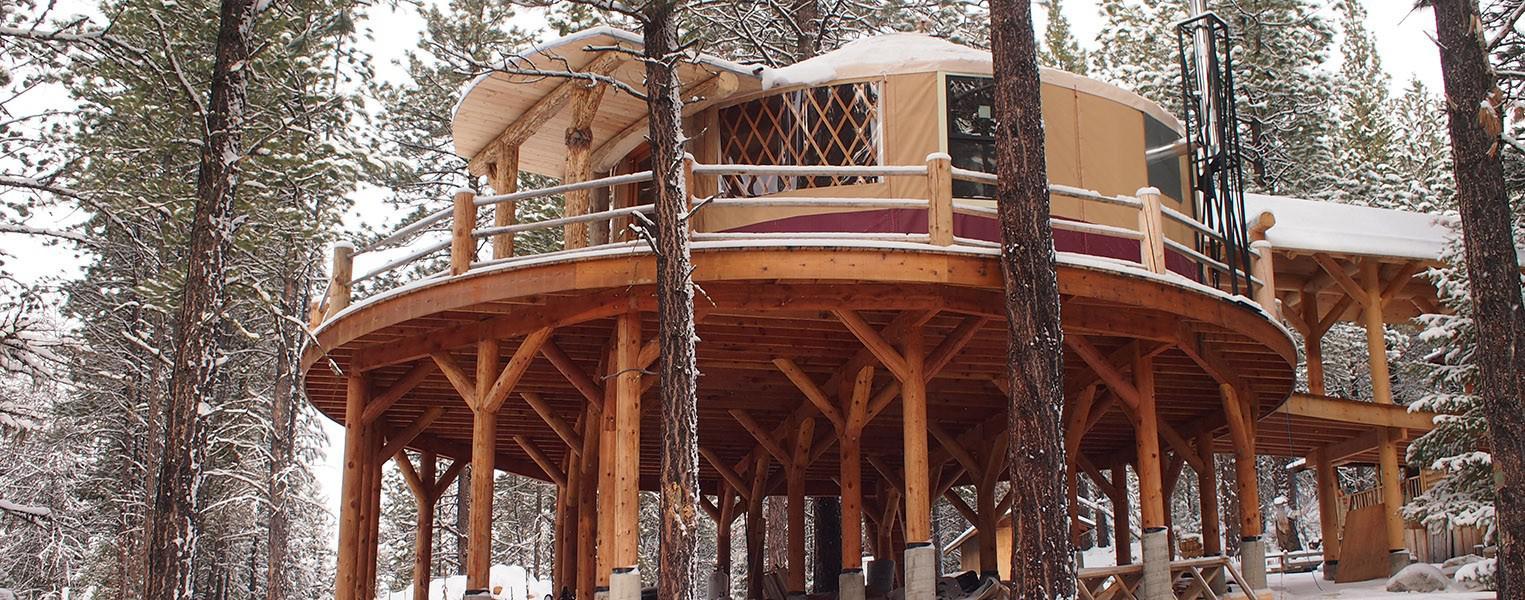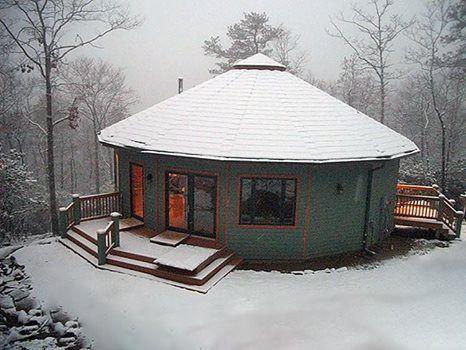The first image is the image on the left, the second image is the image on the right. Evaluate the accuracy of this statement regarding the images: "An image shows a round structure surrounded by a round railed deck, and the structure has lattice-work showing in the windows.". Is it true? Answer yes or no. Yes. The first image is the image on the left, the second image is the image on the right. Analyze the images presented: Is the assertion "Each image shows the snowy winter exterior of a yurt, with decking of wooden posts and railings." valid? Answer yes or no. Yes. 